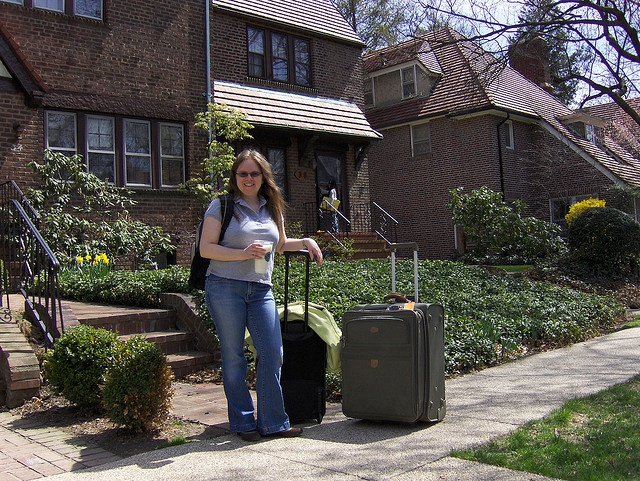Describe the objects in this image and their specific colors. I can see people in gray, navy, and black tones, suitcase in gray, black, and darkgray tones, suitcase in gray, black, darkgreen, and beige tones, handbag in gray and black tones, and backpack in gray, black, darkgreen, and purple tones in this image. 